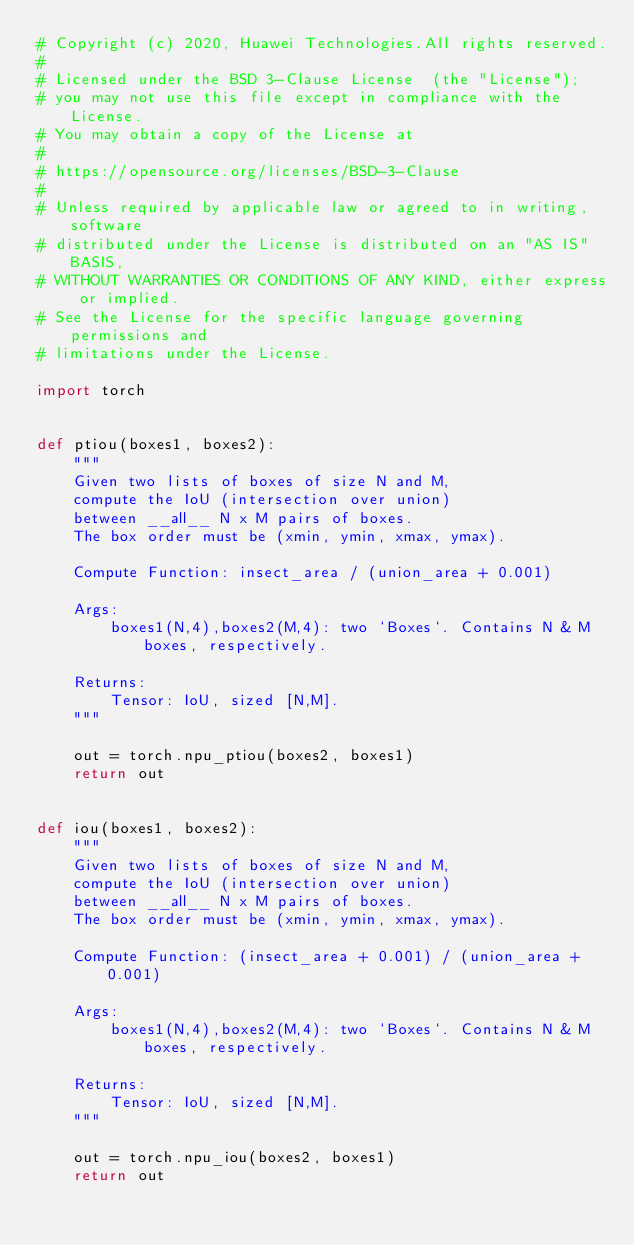<code> <loc_0><loc_0><loc_500><loc_500><_Python_># Copyright (c) 2020, Huawei Technologies.All rights reserved.
#
# Licensed under the BSD 3-Clause License  (the "License");
# you may not use this file except in compliance with the License.
# You may obtain a copy of the License at
#
# https://opensource.org/licenses/BSD-3-Clause
#
# Unless required by applicable law or agreed to in writing, software
# distributed under the License is distributed on an "AS IS" BASIS,
# WITHOUT WARRANTIES OR CONDITIONS OF ANY KIND, either express or implied.
# See the License for the specific language governing permissions and
# limitations under the License.

import torch


def ptiou(boxes1, boxes2):
    """
    Given two lists of boxes of size N and M,
    compute the IoU (intersection over union)
    between __all__ N x M pairs of boxes.
    The box order must be (xmin, ymin, xmax, ymax).

    Compute Function: insect_area / (union_area + 0.001)

    Args:
        boxes1(N,4),boxes2(M,4): two `Boxes`. Contains N & M boxes, respectively.

    Returns:
        Tensor: IoU, sized [N,M].
    """

    out = torch.npu_ptiou(boxes2, boxes1)
    return out


def iou(boxes1, boxes2):
    """
    Given two lists of boxes of size N and M,
    compute the IoU (intersection over union)
    between __all__ N x M pairs of boxes.
    The box order must be (xmin, ymin, xmax, ymax).

    Compute Function: (insect_area + 0.001) / (union_area + 0.001)

    Args:
        boxes1(N,4),boxes2(M,4): two `Boxes`. Contains N & M boxes, respectively.

    Returns:
        Tensor: IoU, sized [N,M].
    """

    out = torch.npu_iou(boxes2, boxes1)
    return out
</code> 